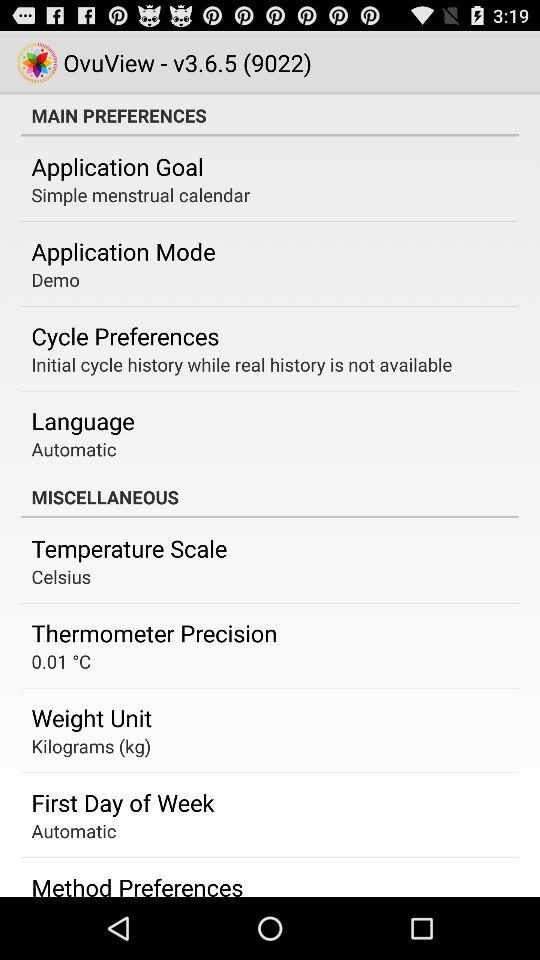What version is used? The version used is v3.6.5 (9022). 